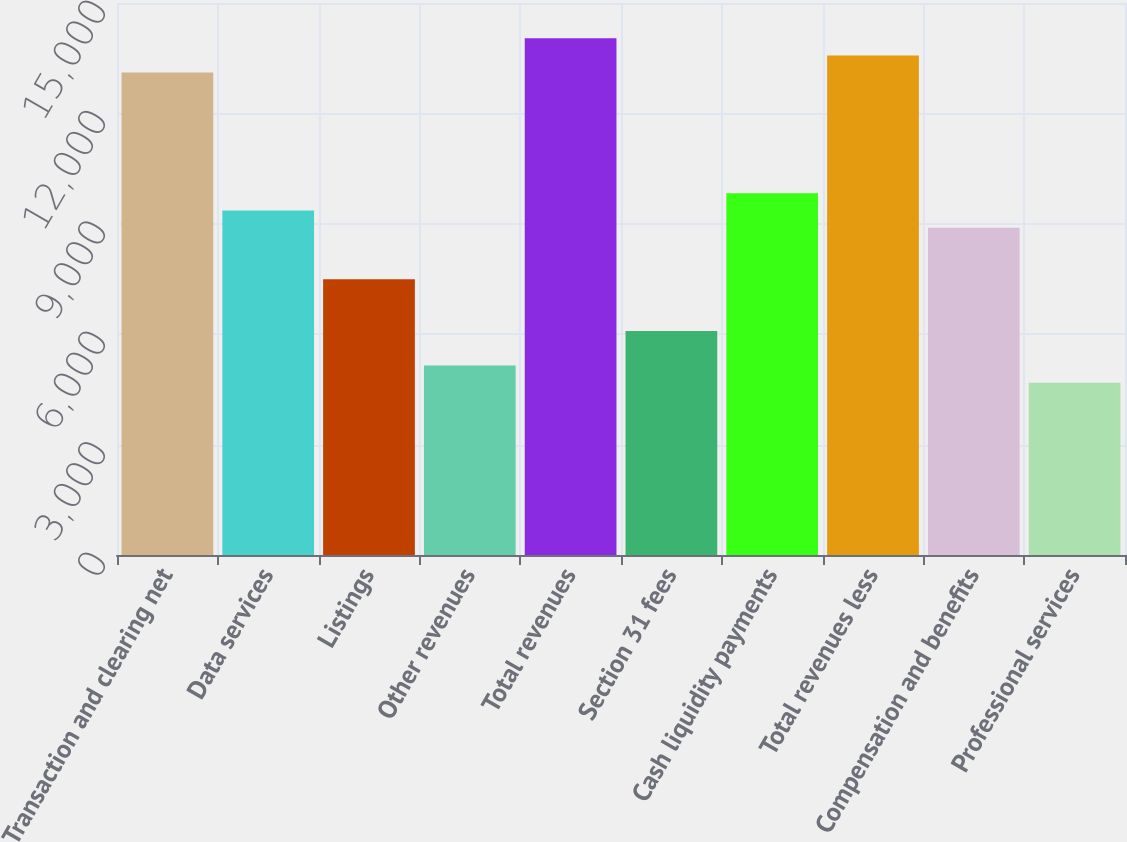Convert chart. <chart><loc_0><loc_0><loc_500><loc_500><bar_chart><fcel>Transaction and clearing net<fcel>Data services<fcel>Listings<fcel>Other revenues<fcel>Total revenues<fcel>Section 31 fees<fcel>Cash liquidity payments<fcel>Total revenues less<fcel>Compensation and benefits<fcel>Professional services<nl><fcel>13108.5<fcel>9363.38<fcel>7490.82<fcel>5150.12<fcel>14044.8<fcel>6086.4<fcel>9831.52<fcel>13576.6<fcel>8895.24<fcel>4681.98<nl></chart> 